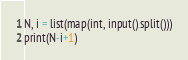<code> <loc_0><loc_0><loc_500><loc_500><_Python_>N, i = list(map(int, input().split()))
print(N-i+1)
</code> 